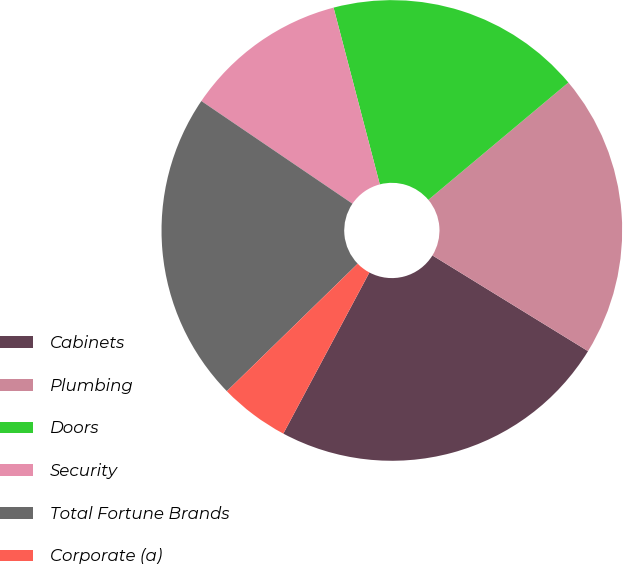Convert chart to OTSL. <chart><loc_0><loc_0><loc_500><loc_500><pie_chart><fcel>Cabinets<fcel>Plumbing<fcel>Doors<fcel>Security<fcel>Total Fortune Brands<fcel>Corporate (a)<nl><fcel>24.03%<fcel>19.88%<fcel>17.97%<fcel>11.43%<fcel>21.79%<fcel>4.9%<nl></chart> 